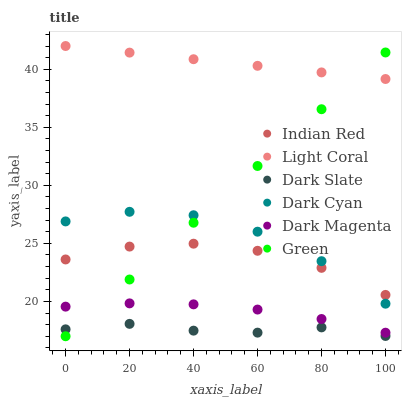Does Dark Slate have the minimum area under the curve?
Answer yes or no. Yes. Does Light Coral have the maximum area under the curve?
Answer yes or no. Yes. Does Light Coral have the minimum area under the curve?
Answer yes or no. No. Does Dark Slate have the maximum area under the curve?
Answer yes or no. No. Is Light Coral the smoothest?
Answer yes or no. Yes. Is Dark Cyan the roughest?
Answer yes or no. Yes. Is Dark Slate the smoothest?
Answer yes or no. No. Is Dark Slate the roughest?
Answer yes or no. No. Does Green have the lowest value?
Answer yes or no. Yes. Does Dark Slate have the lowest value?
Answer yes or no. No. Does Light Coral have the highest value?
Answer yes or no. Yes. Does Dark Slate have the highest value?
Answer yes or no. No. Is Dark Magenta less than Indian Red?
Answer yes or no. Yes. Is Light Coral greater than Dark Magenta?
Answer yes or no. Yes. Does Green intersect Indian Red?
Answer yes or no. Yes. Is Green less than Indian Red?
Answer yes or no. No. Is Green greater than Indian Red?
Answer yes or no. No. Does Dark Magenta intersect Indian Red?
Answer yes or no. No. 